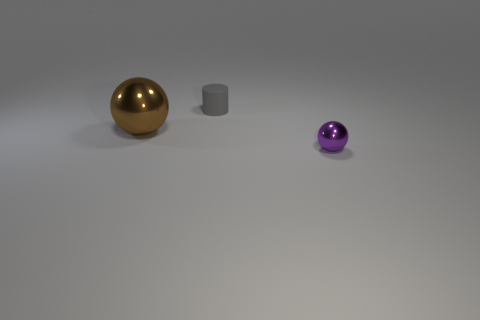How many objects are on the right side of the large brown ball and left of the small matte cylinder?
Provide a short and direct response. 0. The metallic thing that is left of the purple shiny ball has what shape?
Provide a succinct answer. Sphere. Are there fewer large spheres to the right of the small gray rubber cylinder than big objects that are to the right of the purple shiny thing?
Your response must be concise. No. Are the ball that is right of the big metal ball and the object that is left of the gray thing made of the same material?
Ensure brevity in your answer.  Yes. The matte object has what shape?
Provide a succinct answer. Cylinder. Are there more gray rubber objects behind the large thing than tiny matte cylinders left of the small gray rubber cylinder?
Your answer should be compact. Yes. Is the shape of the metallic object left of the small shiny thing the same as the small object that is on the left side of the tiny metallic object?
Offer a terse response. No. How many other things are there of the same size as the brown sphere?
Offer a very short reply. 0. How big is the brown sphere?
Give a very brief answer. Large. Do the purple thing on the right side of the matte thing and the small gray thing have the same material?
Your answer should be very brief. No. 